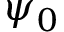Convert formula to latex. <formula><loc_0><loc_0><loc_500><loc_500>\psi _ { 0 }</formula> 